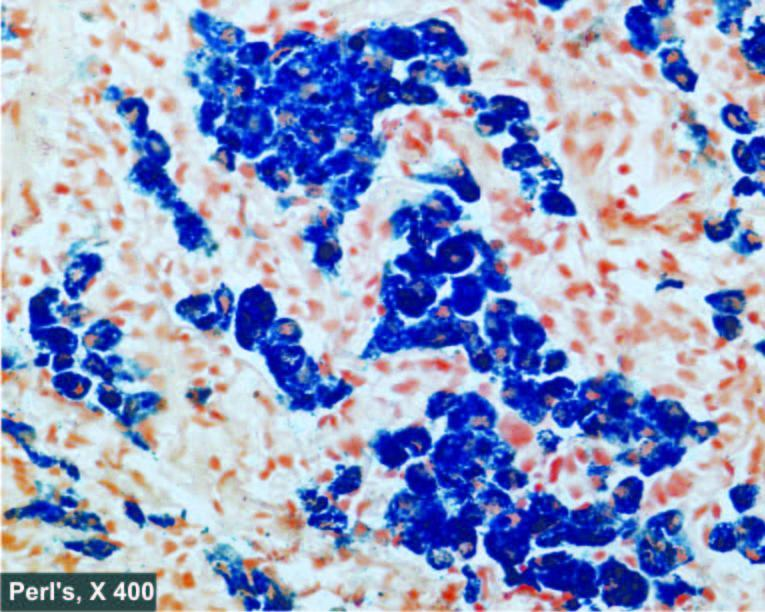re haemosiderin pigment in the cytoplasm of hepatocytes see as prussian blue granules?
Answer the question using a single word or phrase. Yes 